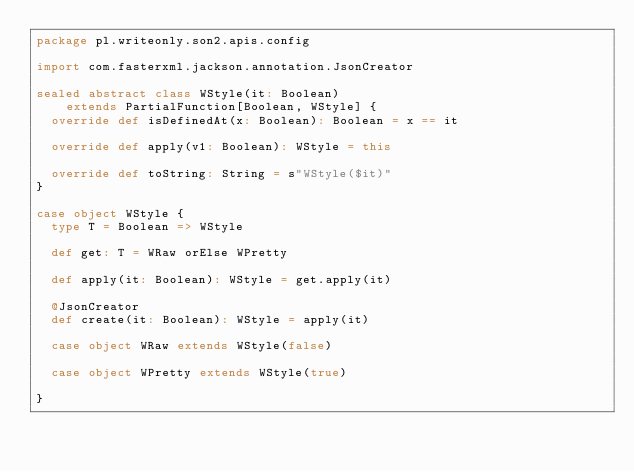<code> <loc_0><loc_0><loc_500><loc_500><_Scala_>package pl.writeonly.son2.apis.config

import com.fasterxml.jackson.annotation.JsonCreator

sealed abstract class WStyle(it: Boolean)
    extends PartialFunction[Boolean, WStyle] {
  override def isDefinedAt(x: Boolean): Boolean = x == it

  override def apply(v1: Boolean): WStyle = this

  override def toString: String = s"WStyle($it)"
}

case object WStyle {
  type T = Boolean => WStyle

  def get: T = WRaw orElse WPretty

  def apply(it: Boolean): WStyle = get.apply(it)

  @JsonCreator
  def create(it: Boolean): WStyle = apply(it)

  case object WRaw extends WStyle(false)

  case object WPretty extends WStyle(true)

}
</code> 